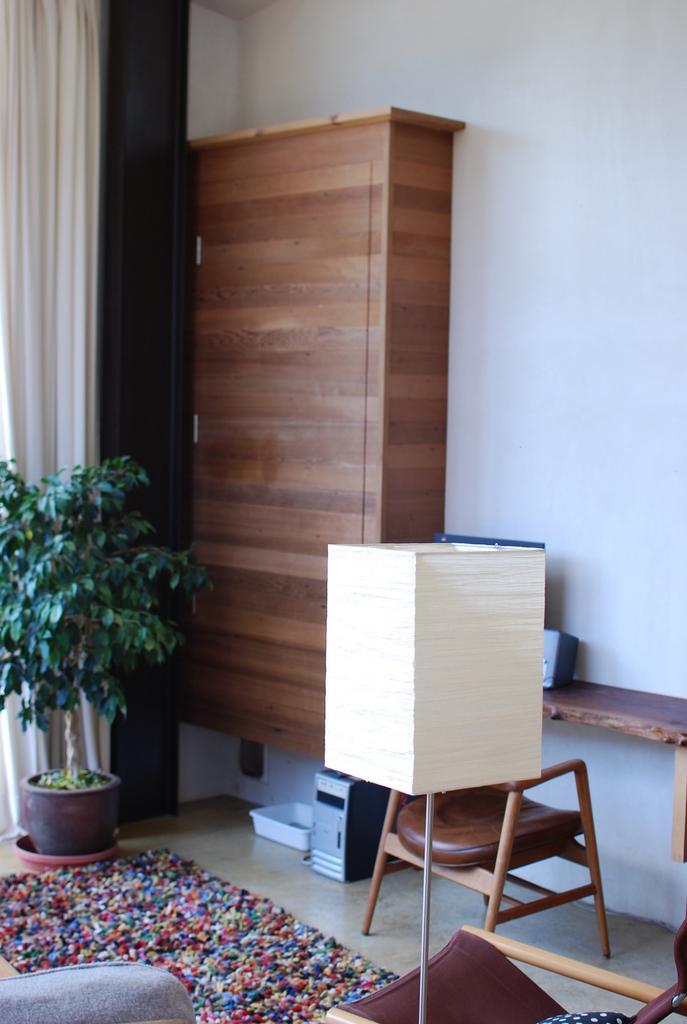How would you summarize this image in a sentence or two? The image is inside the room. In the image on right side we can see a chair, table on table there is a speaker and we can also see in background plant with some flower pot,curtains in white color,tree. in background there is a wall which is in white color. 